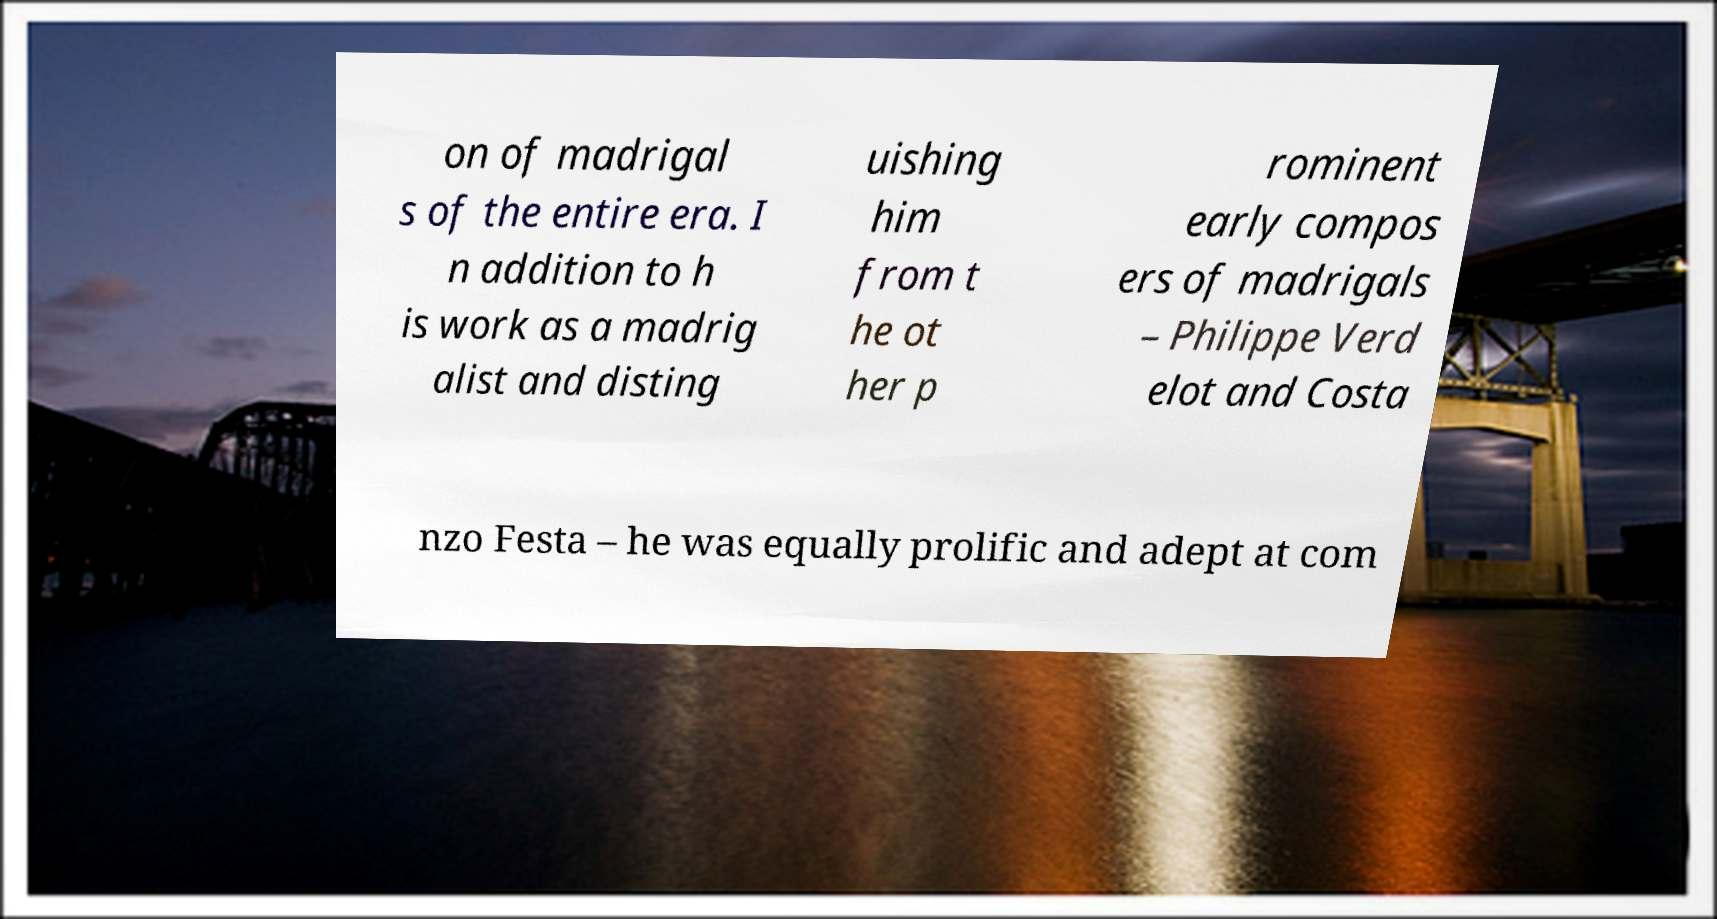There's text embedded in this image that I need extracted. Can you transcribe it verbatim? on of madrigal s of the entire era. I n addition to h is work as a madrig alist and disting uishing him from t he ot her p rominent early compos ers of madrigals – Philippe Verd elot and Costa nzo Festa – he was equally prolific and adept at com 